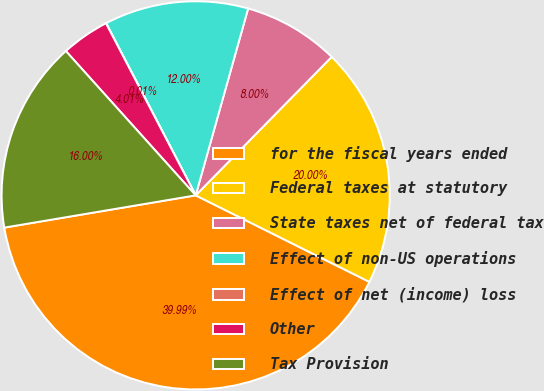Convert chart. <chart><loc_0><loc_0><loc_500><loc_500><pie_chart><fcel>for the fiscal years ended<fcel>Federal taxes at statutory<fcel>State taxes net of federal tax<fcel>Effect of non-US operations<fcel>Effect of net (income) loss<fcel>Other<fcel>Tax Provision<nl><fcel>39.99%<fcel>20.0%<fcel>8.0%<fcel>12.0%<fcel>0.01%<fcel>4.01%<fcel>16.0%<nl></chart> 